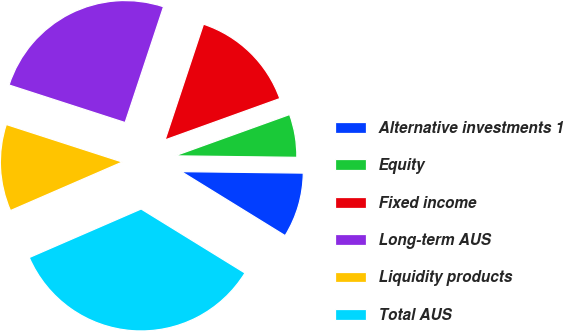Convert chart to OTSL. <chart><loc_0><loc_0><loc_500><loc_500><pie_chart><fcel>Alternative investments 1<fcel>Equity<fcel>Fixed income<fcel>Long-term AUS<fcel>Liquidity products<fcel>Total AUS<nl><fcel>8.6%<fcel>5.7%<fcel>14.4%<fcel>25.12%<fcel>11.5%<fcel>34.69%<nl></chart> 